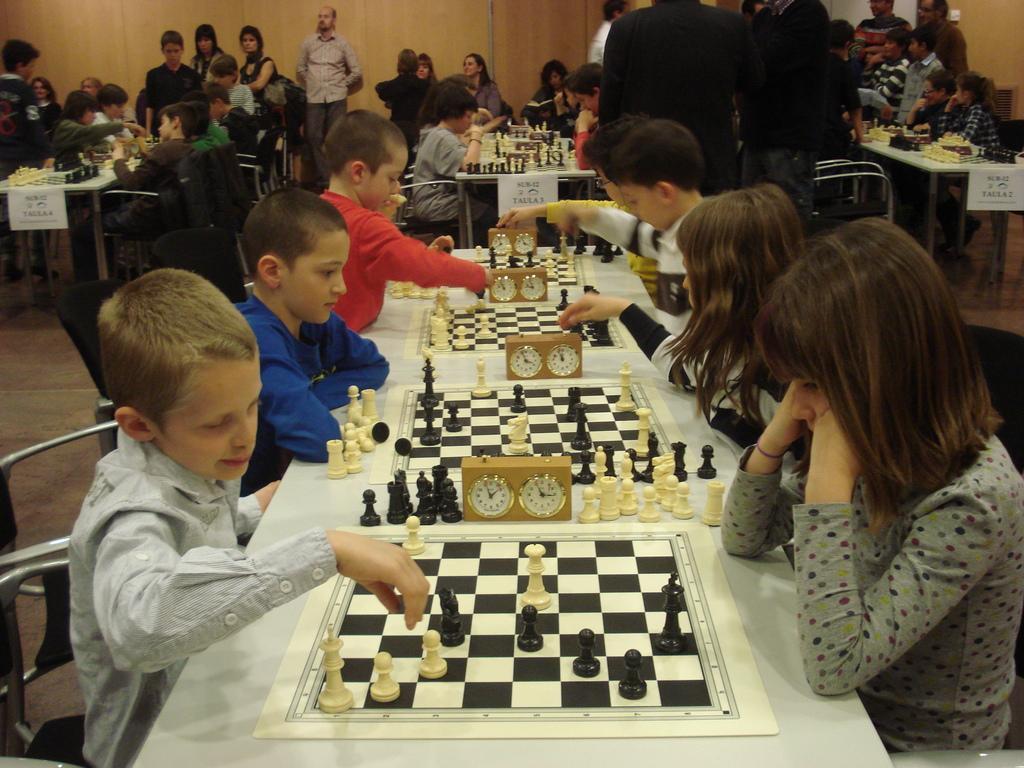Can you describe this image briefly? In this image there are many chess boards clocks there on table. Kids are playing chess. They are sitting on chairs. Few people are standing in the mage. 